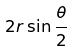<formula> <loc_0><loc_0><loc_500><loc_500>2 r \sin \frac { \theta } { 2 }</formula> 